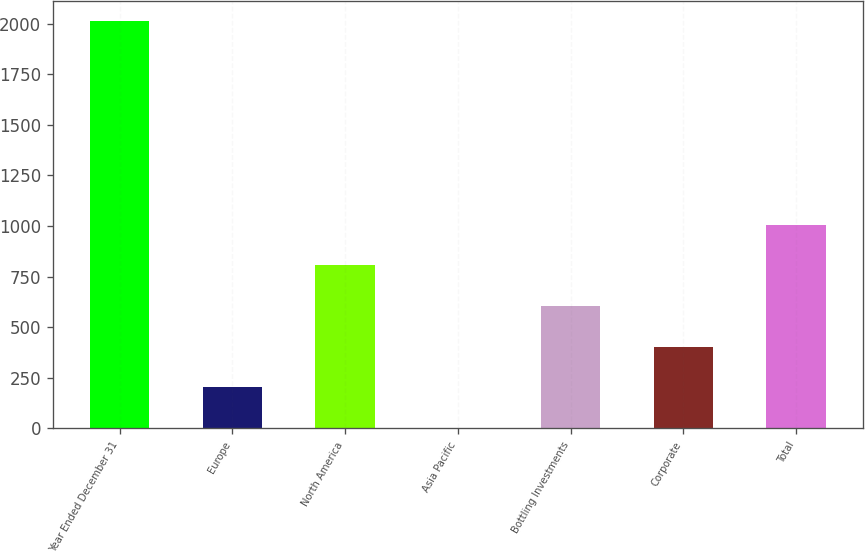Convert chart to OTSL. <chart><loc_0><loc_0><loc_500><loc_500><bar_chart><fcel>Year Ended December 31<fcel>Europe<fcel>North America<fcel>Asia Pacific<fcel>Bottling Investments<fcel>Corporate<fcel>Total<nl><fcel>2012<fcel>202.1<fcel>805.4<fcel>1<fcel>604.3<fcel>403.2<fcel>1006.5<nl></chart> 